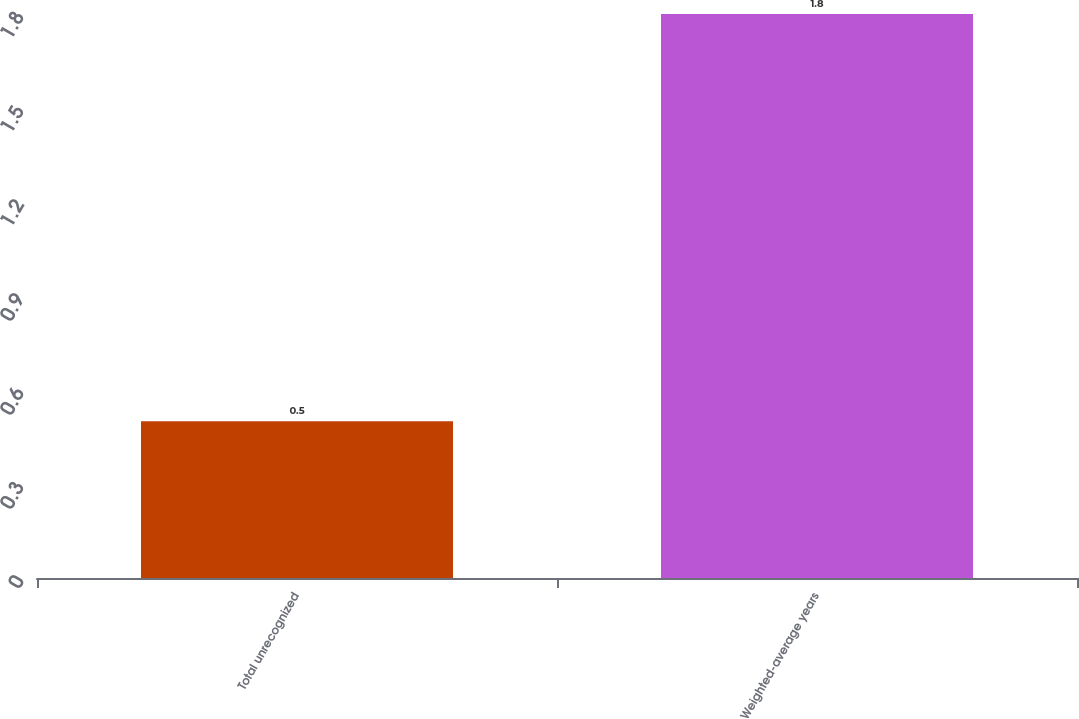Convert chart. <chart><loc_0><loc_0><loc_500><loc_500><bar_chart><fcel>Total unrecognized<fcel>Weighted-average years<nl><fcel>0.5<fcel>1.8<nl></chart> 